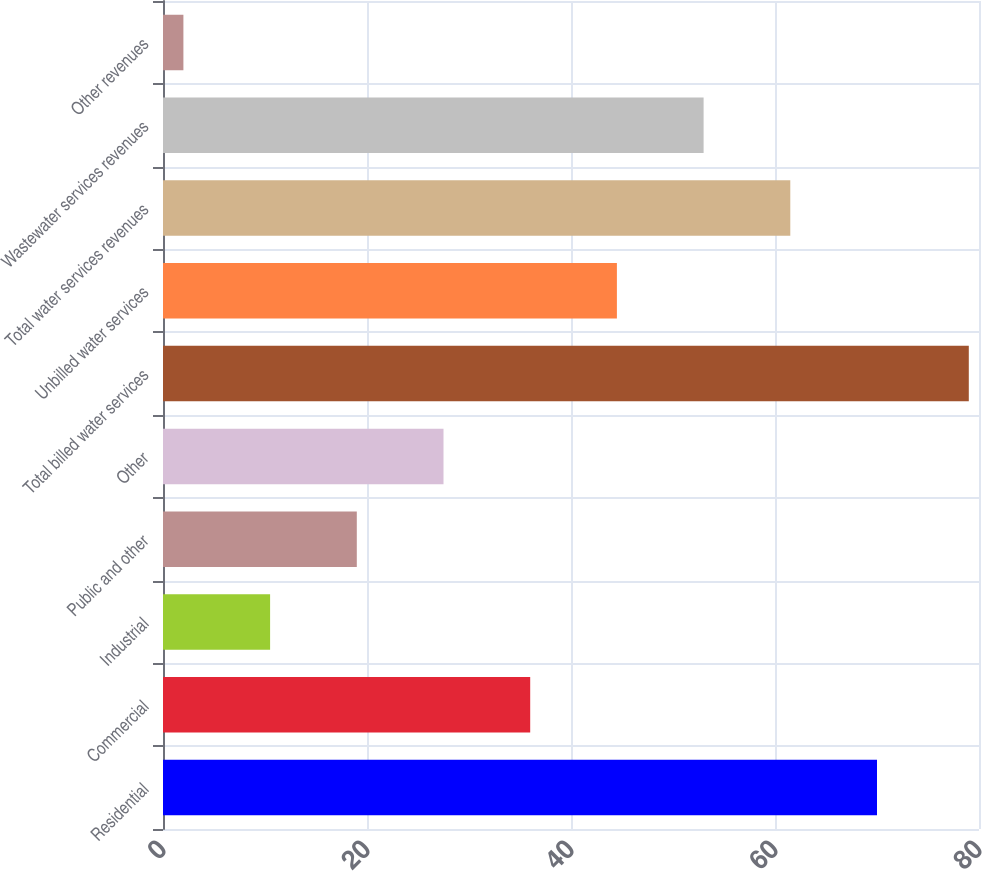<chart> <loc_0><loc_0><loc_500><loc_500><bar_chart><fcel>Residential<fcel>Commercial<fcel>Industrial<fcel>Public and other<fcel>Other<fcel>Total billed water services<fcel>Unbilled water services<fcel>Total water services revenues<fcel>Wastewater services revenues<fcel>Other revenues<nl><fcel>70<fcel>36<fcel>10.5<fcel>19<fcel>27.5<fcel>79<fcel>44.5<fcel>61.5<fcel>53<fcel>2<nl></chart> 